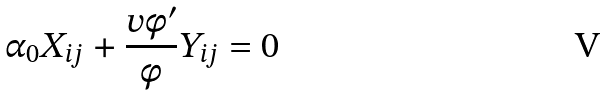Convert formula to latex. <formula><loc_0><loc_0><loc_500><loc_500>\alpha _ { 0 } X _ { i j } + \frac { v \phi ^ { \prime } } { \phi } Y _ { i j } = 0</formula> 